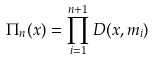Convert formula to latex. <formula><loc_0><loc_0><loc_500><loc_500>\Pi _ { n } ( x ) = \prod _ { i = 1 } ^ { n + 1 } D ( x , m _ { i } )</formula> 